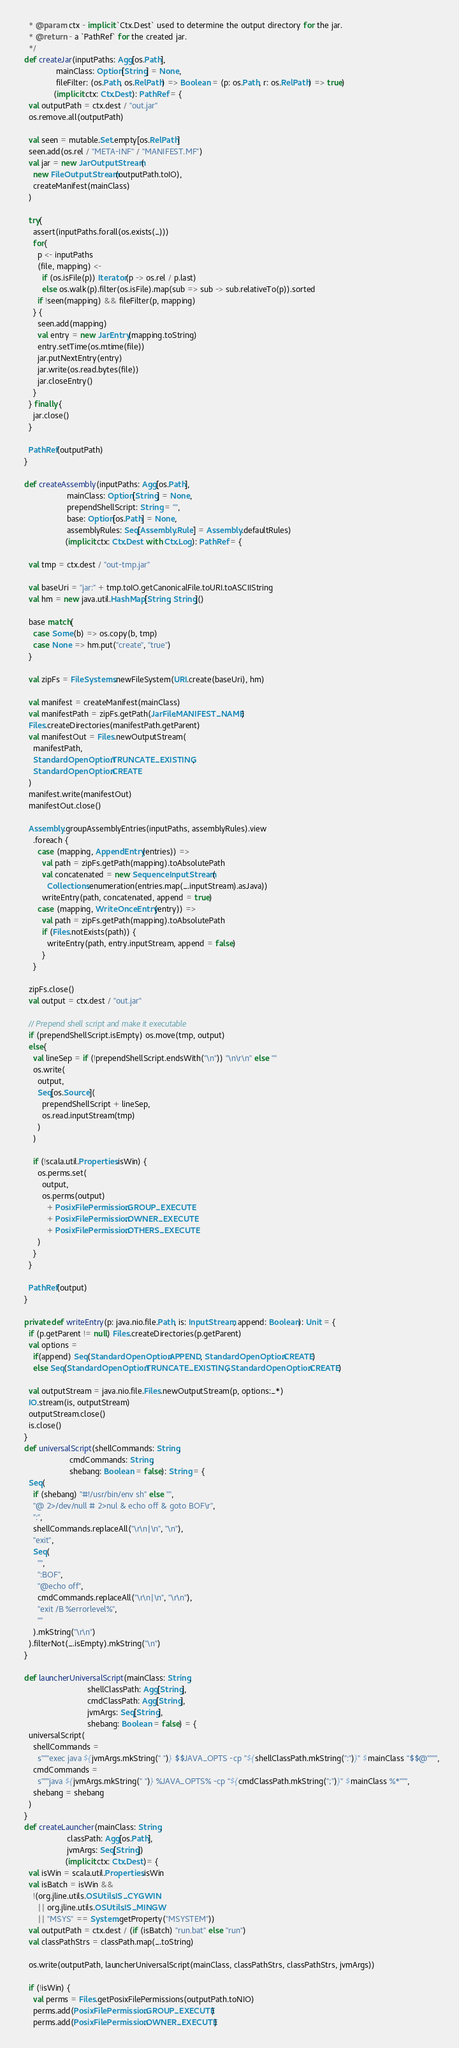Convert code to text. <code><loc_0><loc_0><loc_500><loc_500><_Scala_>    * @param ctx - implicit `Ctx.Dest` used to determine the output directory for the jar.
    * @return - a `PathRef` for the created jar.
    */
  def createJar(inputPaths: Agg[os.Path],
                mainClass: Option[String] = None,
                fileFilter: (os.Path, os.RelPath) => Boolean = (p: os.Path, r: os.RelPath) => true)
               (implicit ctx: Ctx.Dest): PathRef = {
    val outputPath = ctx.dest / "out.jar"
    os.remove.all(outputPath)

    val seen = mutable.Set.empty[os.RelPath]
    seen.add(os.rel / "META-INF" / "MANIFEST.MF")
    val jar = new JarOutputStream(
      new FileOutputStream(outputPath.toIO),
      createManifest(mainClass)
    )

    try{
      assert(inputPaths.forall(os.exists(_)))
      for{
        p <- inputPaths
        (file, mapping) <-
          if (os.isFile(p)) Iterator(p -> os.rel / p.last)
          else os.walk(p).filter(os.isFile).map(sub => sub -> sub.relativeTo(p)).sorted
        if !seen(mapping) && fileFilter(p, mapping)
      } {
        seen.add(mapping)
        val entry = new JarEntry(mapping.toString)
        entry.setTime(os.mtime(file))
        jar.putNextEntry(entry)
        jar.write(os.read.bytes(file))
        jar.closeEntry()
      }
    } finally {
      jar.close()
    }

    PathRef(outputPath)
  }

  def createAssembly(inputPaths: Agg[os.Path],
                     mainClass: Option[String] = None,
                     prependShellScript: String = "",
                     base: Option[os.Path] = None,
                     assemblyRules: Seq[Assembly.Rule] = Assembly.defaultRules)
                    (implicit ctx: Ctx.Dest with Ctx.Log): PathRef = {

    val tmp = ctx.dest / "out-tmp.jar"

    val baseUri = "jar:" + tmp.toIO.getCanonicalFile.toURI.toASCIIString
    val hm = new java.util.HashMap[String, String]()

    base match{
      case Some(b) => os.copy(b, tmp)
      case None => hm.put("create", "true")
    }

    val zipFs = FileSystems.newFileSystem(URI.create(baseUri), hm)

    val manifest = createManifest(mainClass)
    val manifestPath = zipFs.getPath(JarFile.MANIFEST_NAME)
    Files.createDirectories(manifestPath.getParent)
    val manifestOut = Files.newOutputStream(
      manifestPath,
      StandardOpenOption.TRUNCATE_EXISTING,
      StandardOpenOption.CREATE
    )
    manifest.write(manifestOut)
    manifestOut.close()

    Assembly.groupAssemblyEntries(inputPaths, assemblyRules).view
      .foreach {
        case (mapping, AppendEntry(entries)) =>
          val path = zipFs.getPath(mapping).toAbsolutePath
          val concatenated = new SequenceInputStream(
            Collections.enumeration(entries.map(_.inputStream).asJava))
          writeEntry(path, concatenated, append = true)
        case (mapping, WriteOnceEntry(entry)) =>
          val path = zipFs.getPath(mapping).toAbsolutePath
          if (Files.notExists(path)) {
            writeEntry(path, entry.inputStream, append = false)
          }
      }

    zipFs.close()
    val output = ctx.dest / "out.jar"

    // Prepend shell script and make it executable
    if (prependShellScript.isEmpty) os.move(tmp, output)
    else{
      val lineSep = if (!prependShellScript.endsWith("\n")) "\n\r\n" else ""
      os.write(
        output,
        Seq[os.Source](
          prependShellScript + lineSep,
          os.read.inputStream(tmp)
        )
      )

      if (!scala.util.Properties.isWin) {
        os.perms.set(
          output,
          os.perms(output)
            + PosixFilePermission.GROUP_EXECUTE
            + PosixFilePermission.OWNER_EXECUTE
            + PosixFilePermission.OTHERS_EXECUTE
        )
      }
    }

    PathRef(output)
  }

  private def writeEntry(p: java.nio.file.Path, is: InputStream, append: Boolean): Unit = {
    if (p.getParent != null) Files.createDirectories(p.getParent)
    val options =
      if(append) Seq(StandardOpenOption.APPEND, StandardOpenOption.CREATE)
      else Seq(StandardOpenOption.TRUNCATE_EXISTING, StandardOpenOption.CREATE)

    val outputStream = java.nio.file.Files.newOutputStream(p, options:_*)
    IO.stream(is, outputStream)
    outputStream.close()
    is.close()
  }
  def universalScript(shellCommands: String,
                      cmdCommands: String,
                      shebang: Boolean = false): String = {
    Seq(
      if (shebang) "#!/usr/bin/env sh" else "",
      "@ 2>/dev/null # 2>nul & echo off & goto BOF\r",
      ":",
      shellCommands.replaceAll("\r\n|\n", "\n"),
      "exit",
      Seq(
        "",
        ":BOF",
        "@echo off",
        cmdCommands.replaceAll("\r\n|\n", "\r\n"),
        "exit /B %errorlevel%",
        ""
      ).mkString("\r\n")
    ).filterNot(_.isEmpty).mkString("\n")
  }

  def launcherUniversalScript(mainClass: String,
                              shellClassPath: Agg[String],
                              cmdClassPath: Agg[String],
                              jvmArgs: Seq[String],
                              shebang: Boolean = false) = {
    universalScript(
      shellCommands =
        s"""exec java ${jvmArgs.mkString(" ")} $$JAVA_OPTS -cp "${shellClassPath.mkString(":")}" $mainClass "$$@"""",
      cmdCommands =
        s"""java ${jvmArgs.mkString(" ")} %JAVA_OPTS% -cp "${cmdClassPath.mkString(";")}" $mainClass %*""",
      shebang = shebang
    )
  }
  def createLauncher(mainClass: String,
                     classPath: Agg[os.Path],
                     jvmArgs: Seq[String])
                    (implicit ctx: Ctx.Dest)= {
    val isWin = scala.util.Properties.isWin
    val isBatch = isWin &&
      !(org.jline.utils.OSUtils.IS_CYGWIN
        || org.jline.utils.OSUtils.IS_MINGW
        || "MSYS" == System.getProperty("MSYSTEM"))
    val outputPath = ctx.dest / (if (isBatch) "run.bat" else "run")
    val classPathStrs = classPath.map(_.toString)

    os.write(outputPath, launcherUniversalScript(mainClass, classPathStrs, classPathStrs, jvmArgs))

    if (!isWin) {
      val perms = Files.getPosixFilePermissions(outputPath.toNIO)
      perms.add(PosixFilePermission.GROUP_EXECUTE)
      perms.add(PosixFilePermission.OWNER_EXECUTE)</code> 